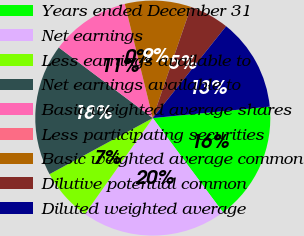Convert chart. <chart><loc_0><loc_0><loc_500><loc_500><pie_chart><fcel>Years ended December 31<fcel>Net earnings<fcel>Less earnings available to<fcel>Net earnings available to<fcel>Basic weighted average shares<fcel>Less participating securities<fcel>Basic weighted average common<fcel>Dilutive potential common<fcel>Diluted weighted average<nl><fcel>16.36%<fcel>19.99%<fcel>7.28%<fcel>18.17%<fcel>10.91%<fcel>0.01%<fcel>9.09%<fcel>5.46%<fcel>12.73%<nl></chart> 